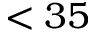Convert formula to latex. <formula><loc_0><loc_0><loc_500><loc_500>< 3 5</formula> 